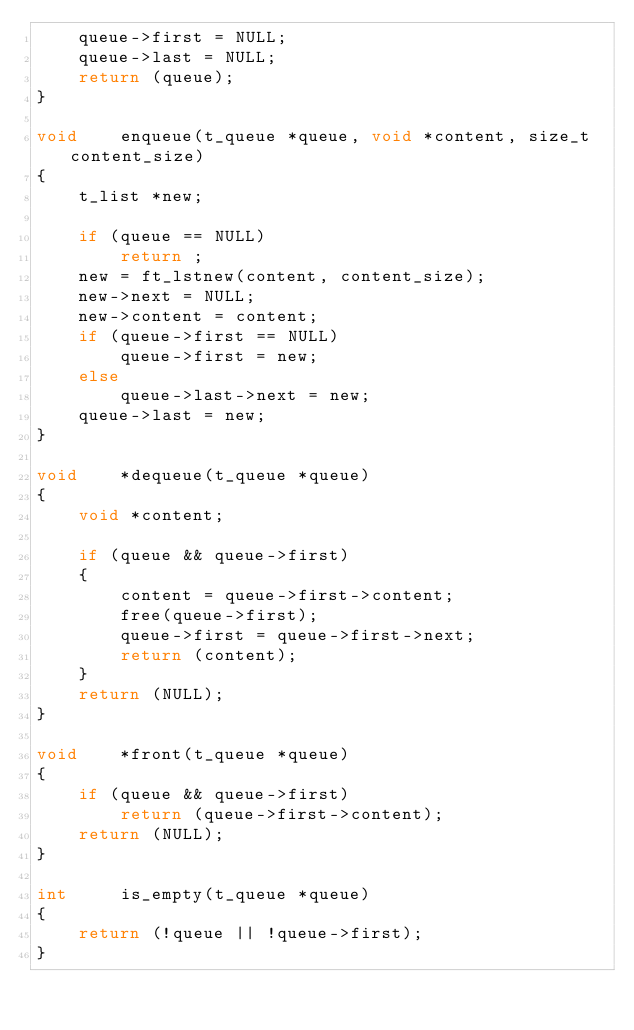Convert code to text. <code><loc_0><loc_0><loc_500><loc_500><_C_>	queue->first = NULL;
	queue->last = NULL;
	return (queue);
}

void	enqueue(t_queue *queue, void *content, size_t content_size)
{
	t_list *new;

	if (queue == NULL)
		return ;
	new = ft_lstnew(content, content_size);
	new->next = NULL;
	new->content = content;
	if (queue->first == NULL)
		queue->first = new;
	else
		queue->last->next = new;
	queue->last = new;
}

void	*dequeue(t_queue *queue)
{
	void *content;

	if (queue && queue->first)
	{
		content = queue->first->content;
		free(queue->first);
		queue->first = queue->first->next;
		return (content);
	}
	return (NULL);
}

void	*front(t_queue *queue)
{
	if (queue && queue->first)
		return (queue->first->content);
	return (NULL);
}

int		is_empty(t_queue *queue)
{
	return (!queue || !queue->first);
}
</code> 